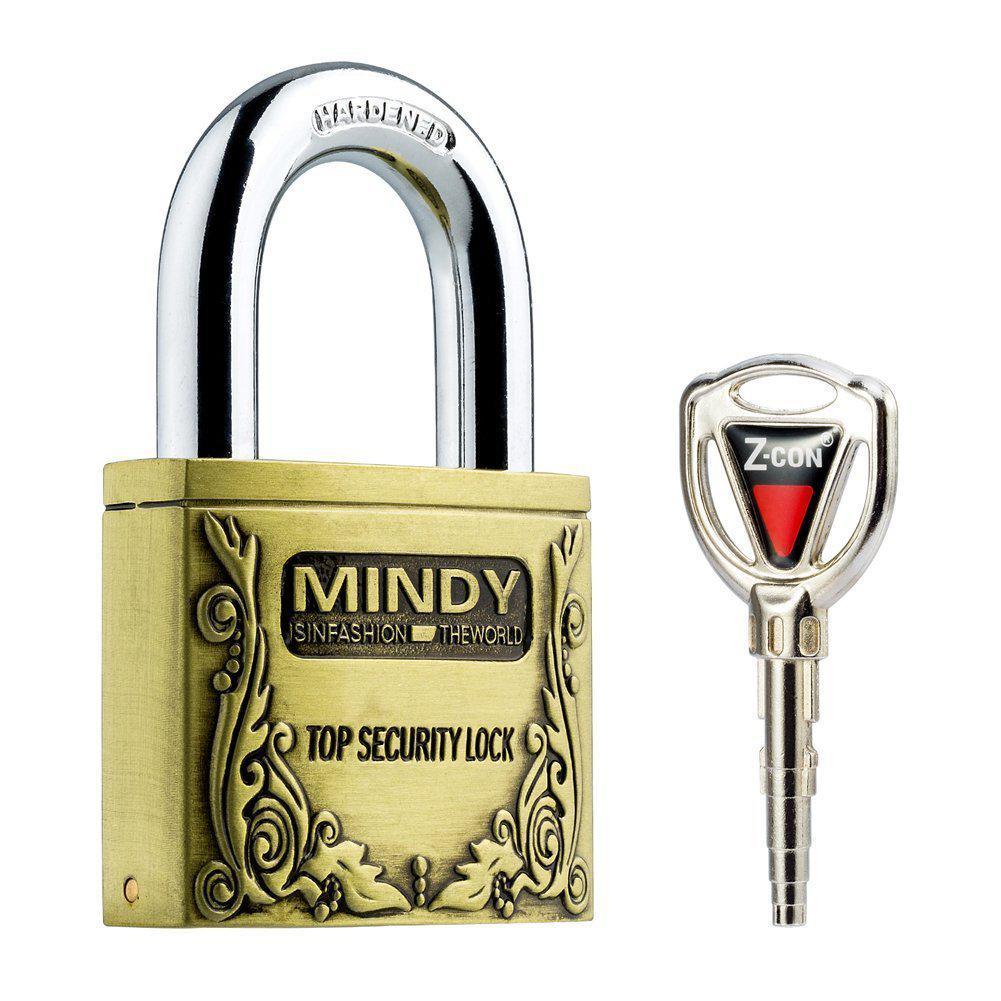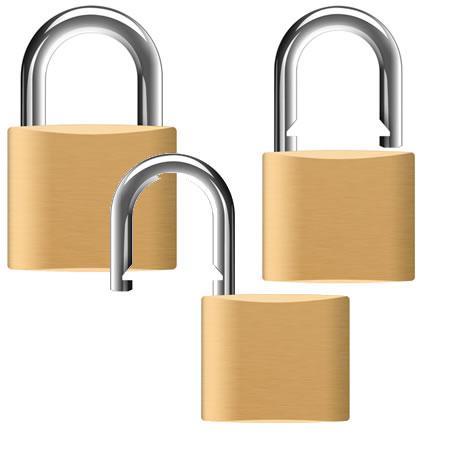The first image is the image on the left, the second image is the image on the right. Given the left and right images, does the statement "There are at least 3 keys on keyrings." hold true? Answer yes or no. No. The first image is the image on the left, the second image is the image on the right. Considering the images on both sides, is "There is only one key." valid? Answer yes or no. Yes. 